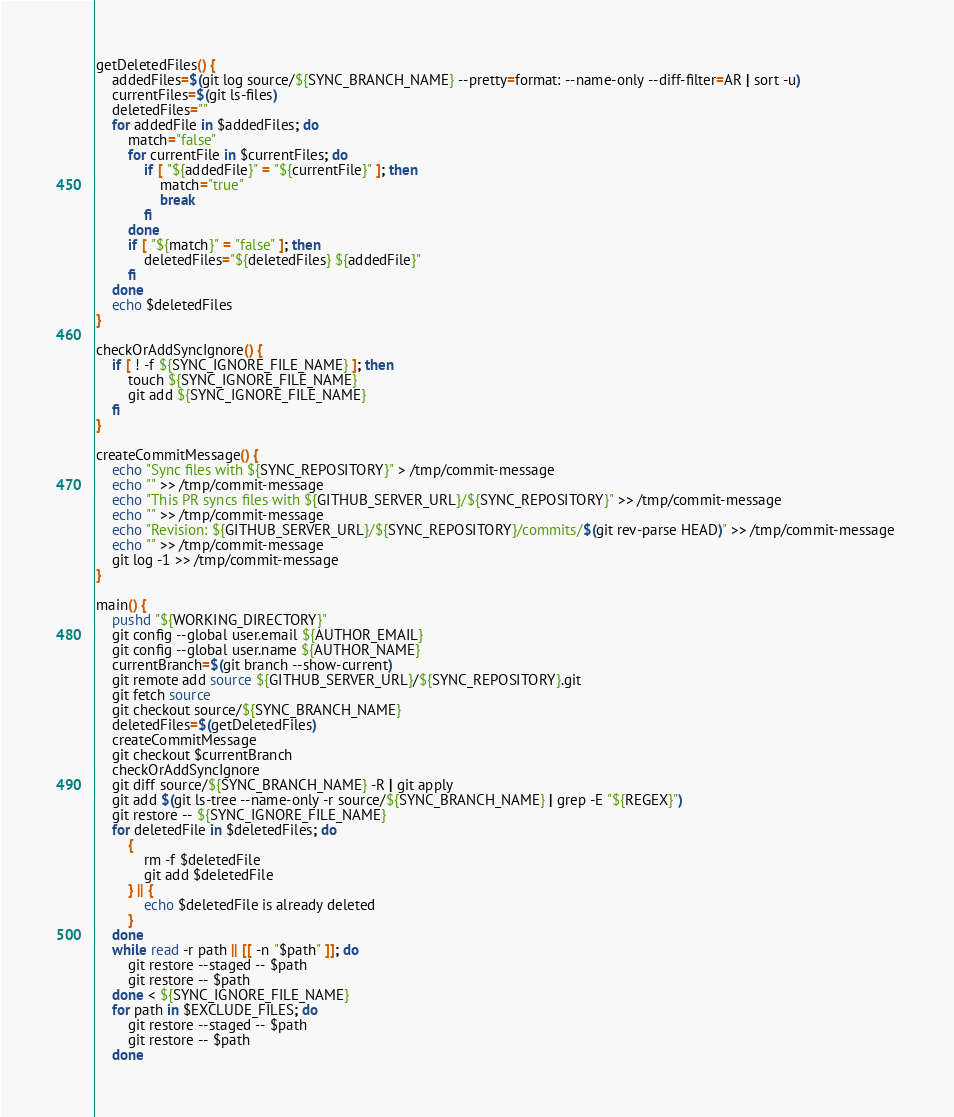<code> <loc_0><loc_0><loc_500><loc_500><_Bash_>getDeletedFiles() {
    addedFiles=$(git log source/${SYNC_BRANCH_NAME} --pretty=format: --name-only --diff-filter=AR | sort -u)
    currentFiles=$(git ls-files)
    deletedFiles=""
    for addedFile in $addedFiles; do 
        match="false"
        for currentFile in $currentFiles; do
            if [ "${addedFile}" = "${currentFile}" ]; then
                match="true"
                break
            fi
        done
        if [ "${match}" = "false" ]; then
            deletedFiles="${deletedFiles} ${addedFile}"
        fi
    done
    echo $deletedFiles
}

checkOrAddSyncIgnore() {
    if [ ! -f ${SYNC_IGNORE_FILE_NAME} ]; then
        touch ${SYNC_IGNORE_FILE_NAME}
        git add ${SYNC_IGNORE_FILE_NAME}
    fi
}

createCommitMessage() {
    echo "Sync files with ${SYNC_REPOSITORY}" > /tmp/commit-message
    echo "" >> /tmp/commit-message
    echo "This PR syncs files with ${GITHUB_SERVER_URL}/${SYNC_REPOSITORY}" >> /tmp/commit-message
    echo "" >> /tmp/commit-message
    echo "Revision: ${GITHUB_SERVER_URL}/${SYNC_REPOSITORY}/commits/$(git rev-parse HEAD)" >> /tmp/commit-message 
    echo "" >> /tmp/commit-message
    git log -1 >> /tmp/commit-message
}

main() {
    pushd "${WORKING_DIRECTORY}"
    git config --global user.email ${AUTHOR_EMAIL}
    git config --global user.name ${AUTHOR_NAME}
    currentBranch=$(git branch --show-current)
    git remote add source ${GITHUB_SERVER_URL}/${SYNC_REPOSITORY}.git
    git fetch source
    git checkout source/${SYNC_BRANCH_NAME}
    deletedFiles=$(getDeletedFiles)
    createCommitMessage
    git checkout $currentBranch
    checkOrAddSyncIgnore
    git diff source/${SYNC_BRANCH_NAME} -R | git apply
    git add $(git ls-tree --name-only -r source/${SYNC_BRANCH_NAME} | grep -E "${REGEX}")
    git restore -- ${SYNC_IGNORE_FILE_NAME}
    for deletedFile in $deletedFiles; do
        {
            rm -f $deletedFile
            git add $deletedFile
        } || {
            echo $deletedFile is already deleted
        }
    done
    while read -r path || [[ -n "$path" ]]; do
        git restore --staged -- $path
        git restore -- $path
    done < ${SYNC_IGNORE_FILE_NAME}
    for path in $EXCLUDE_FILES; do
        git restore --staged -- $path
        git restore -- $path
    done</code> 